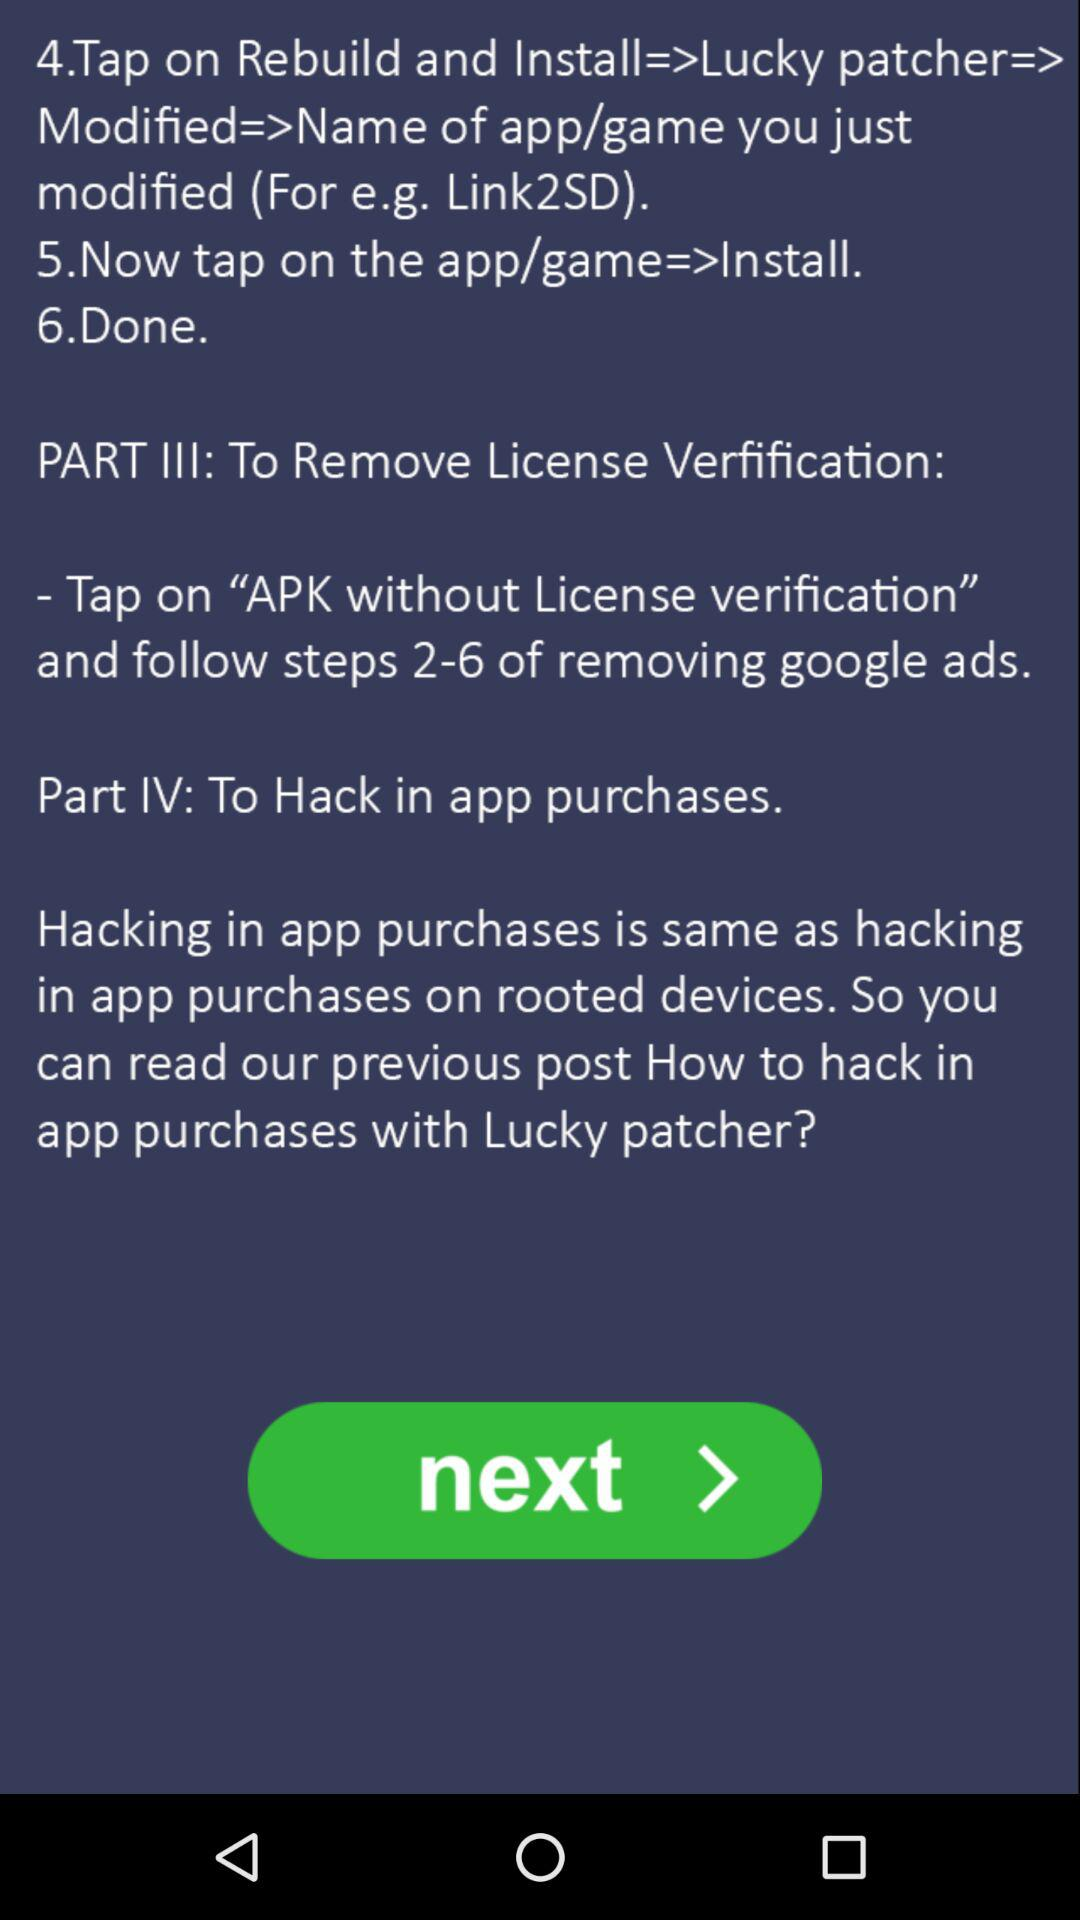How many steps are there in the process to remove license verification?
Answer the question using a single word or phrase. 6 